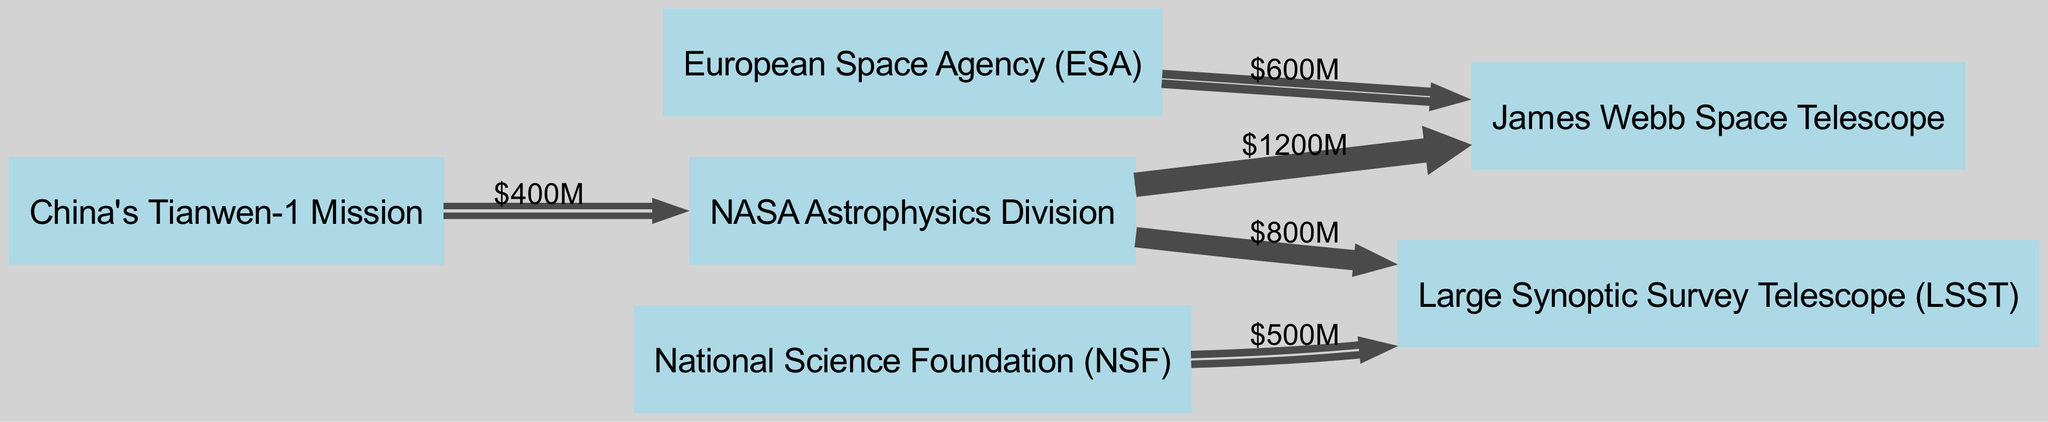What is the total funding from NASA Astrophysics Division to the James Webb Space Telescope? The diagram shows an arrow from NASA Astrophysics Division to James Webb Space Telescope with a label of $1200M. This indicates that NASA allocated 1200 million dollars in funding to the telescope.
Answer: 1200 million dollars Which organization provided funding for the Large Synoptic Survey Telescope (LSST)? The diagram has two edges leading to LSST: one from NASA Astrophysics Division with $800M and one from National Science Foundation with $500M. Therefore, both organizations contributed funding to LSST.
Answer: NASA Astrophysics Division and National Science Foundation How much more funding did NASA Astrophysics Division allocate to the James Webb Space Telescope than to the Large Synoptic Survey Telescope? NASA allocated $1200M to James Webb Space Telescope and $800M to LSST. Subtracting these values ($1200M - $800M) results in a difference of $400M.
Answer: 400 million dollars What is the total funding received by the James Webb Space Telescope from both NASA and ESA? The James Webb Space Telescope received funding from NASA ($1200M) and ESA ($600M). Adding these amounts ($1200M + $600M) provides a total funding of $1800M received by the telescope.
Answer: 1800 million dollars Which node has the highest inflow of funding in the diagram? By examining the incoming flows, James Webb Space Telescope has funding from NASA ($1200M) and ESA ($600M), totaling $1800M. This is more than any other node, as LSST has $1300M combined from NASA and NSF. Therefore, James Webb Space Telescope has the highest inflow.
Answer: James Webb Space Telescope How much funding did China's Tianwen-1 Mission allocate to NASA Astrophysics Division? The diagram shows an arrow from China's Tianwen-1 Mission to NASA Astrophysics Division labeled $400M, indicating this is the amount allocated to it.
Answer: 400 million dollars How many total nodes are present in the diagram? The diagram lists 6 distinct nodes: NASA Astrophysics Division, European Space Agency (ESA), National Science Foundation (NSF), James Webb Space Telescope, Large Synoptic Survey Telescope (LSST), and China's Tianwen-1 Mission. Counting these nodes gives a total of 6.
Answer: 6 What is the total funding allocated to the Large Synoptic Survey Telescope (LSST)? LSST receives $800M from NASA and $500M from NSF. Total funding is calculated by adding these values ($800M + $500M), resulting in $1300M allocated to LSST.
Answer: 1300 million dollars 